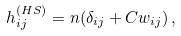<formula> <loc_0><loc_0><loc_500><loc_500>h _ { i j } ^ { ( H S ) } = n ( \delta _ { i j } + C w _ { i j } ) \, ,</formula> 